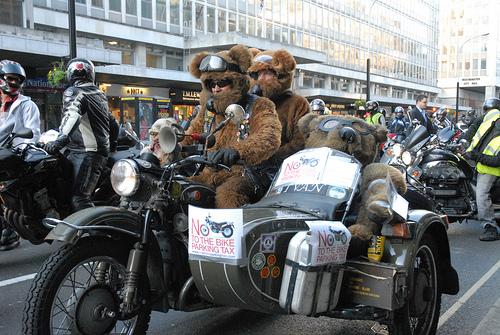What are the people protesting?
Short answer required. Bike parking tax. Are there any teddy bears on the bikes?
Short answer required. Yes. Is there a person in the sidecar?
Give a very brief answer. No. 